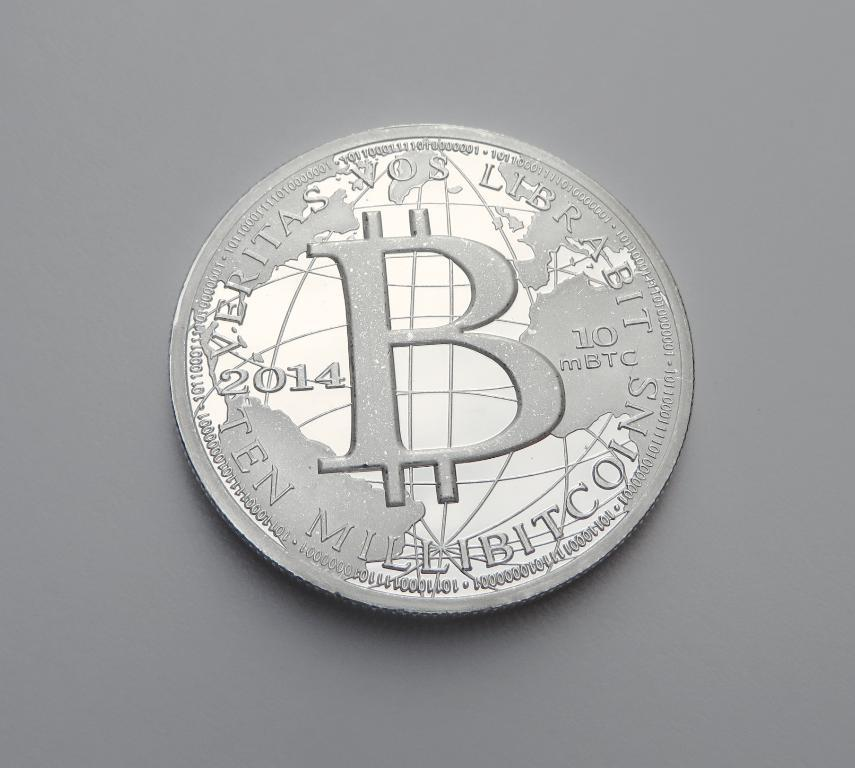<image>
Share a concise interpretation of the image provided. a silver coin that says 'ten millibitcoins' on it 